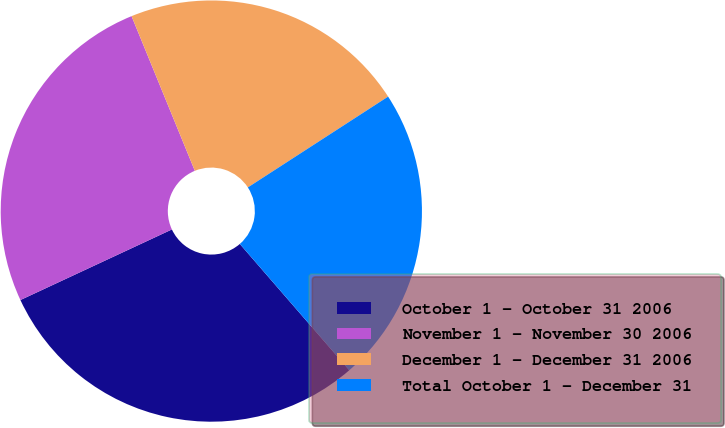<chart> <loc_0><loc_0><loc_500><loc_500><pie_chart><fcel>October 1 - October 31 2006<fcel>November 1 - November 30 2006<fcel>December 1 - December 31 2006<fcel>Total October 1 - December 31<nl><fcel>29.43%<fcel>25.76%<fcel>22.04%<fcel>22.78%<nl></chart> 